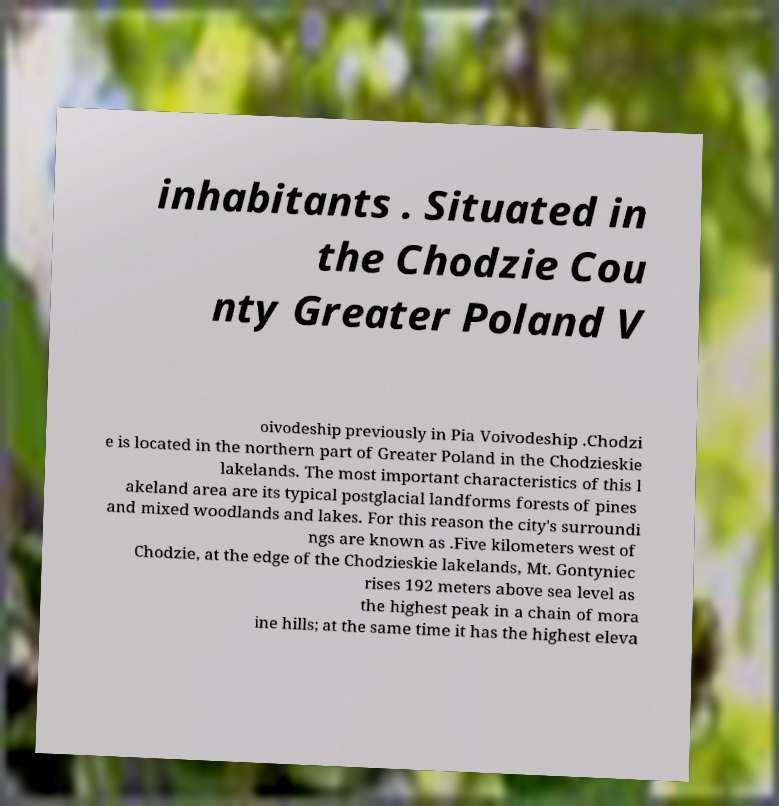I need the written content from this picture converted into text. Can you do that? inhabitants . Situated in the Chodzie Cou nty Greater Poland V oivodeship previously in Pia Voivodeship .Chodzi e is located in the northern part of Greater Poland in the Chodzieskie lakelands. The most important characteristics of this l akeland area are its typical postglacial landforms forests of pines and mixed woodlands and lakes. For this reason the city's surroundi ngs are known as .Five kilometers west of Chodzie, at the edge of the Chodzieskie lakelands, Mt. Gontyniec rises 192 meters above sea level as the highest peak in a chain of mora ine hills; at the same time it has the highest eleva 